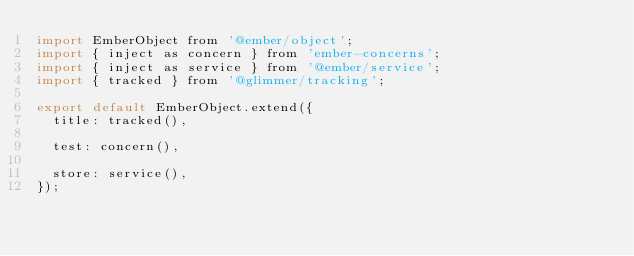Convert code to text. <code><loc_0><loc_0><loc_500><loc_500><_JavaScript_>import EmberObject from '@ember/object';
import { inject as concern } from 'ember-concerns';
import { inject as service } from '@ember/service';
import { tracked } from '@glimmer/tracking';

export default EmberObject.extend({
  title: tracked(),

  test: concern(),

  store: service(),
});
</code> 